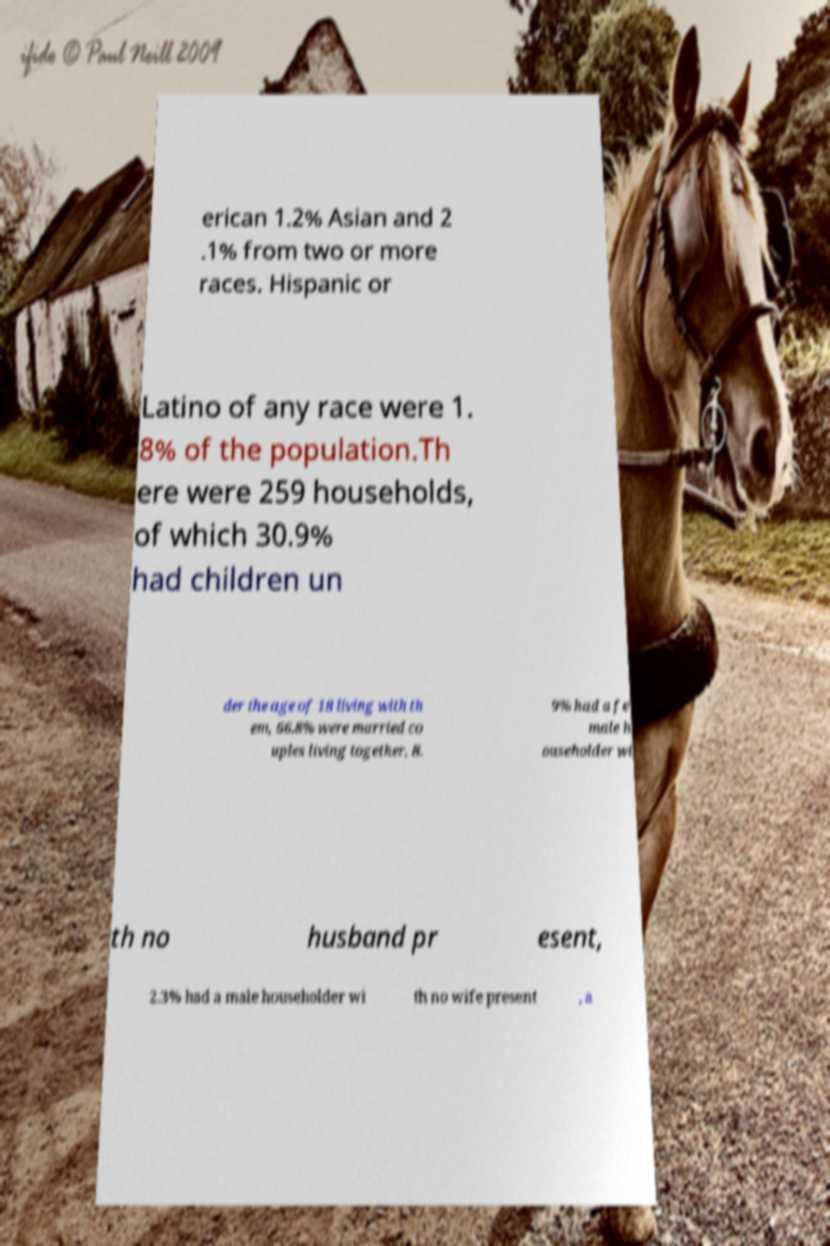Can you accurately transcribe the text from the provided image for me? erican 1.2% Asian and 2 .1% from two or more races. Hispanic or Latino of any race were 1. 8% of the population.Th ere were 259 households, of which 30.9% had children un der the age of 18 living with th em, 66.8% were married co uples living together, 8. 9% had a fe male h ouseholder wi th no husband pr esent, 2.3% had a male householder wi th no wife present , a 